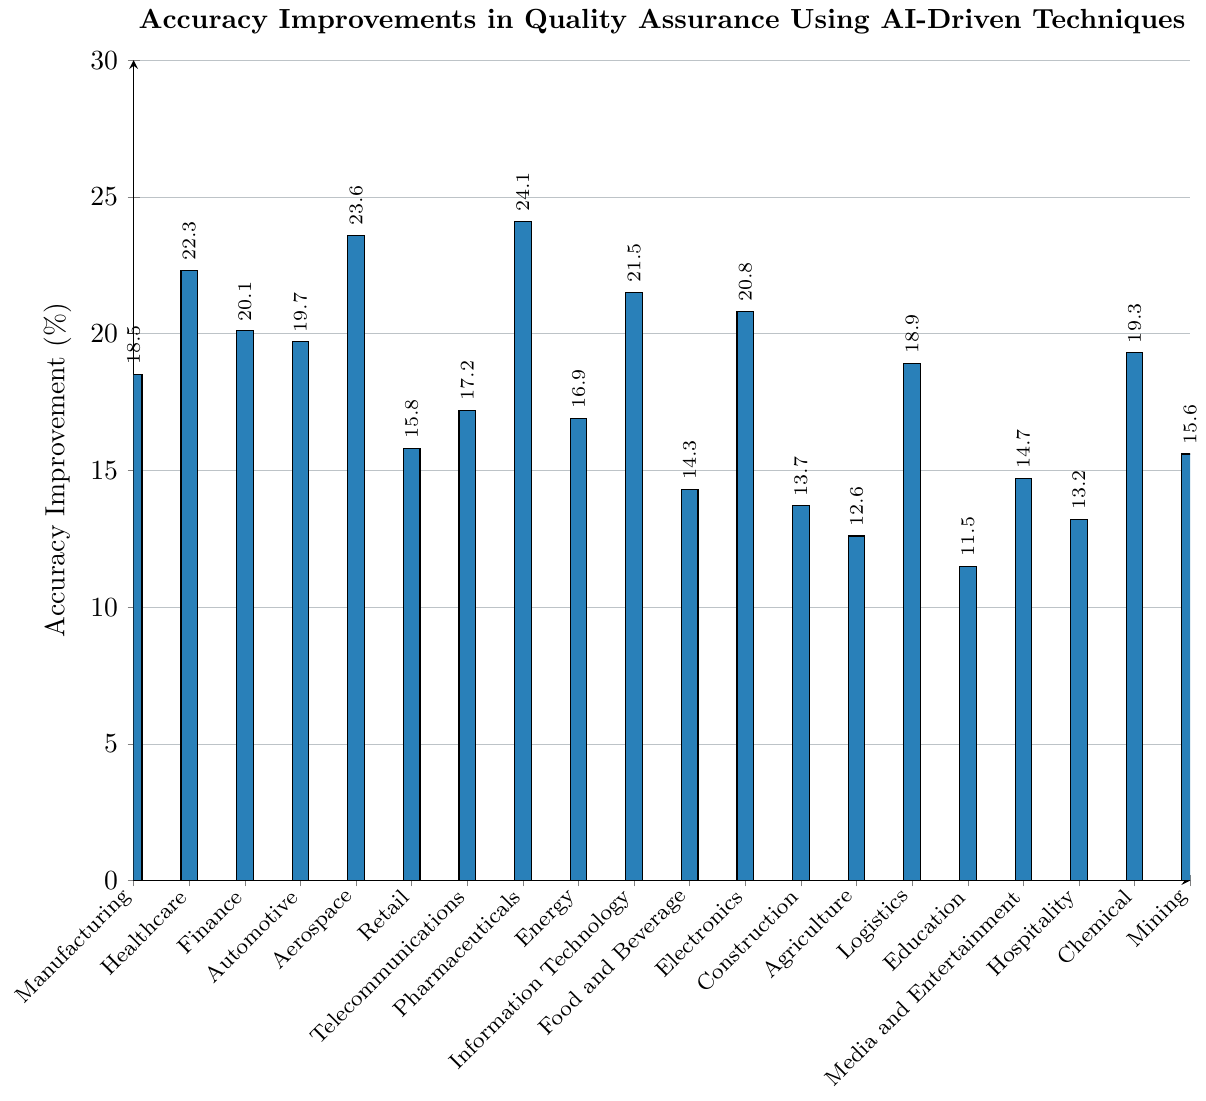Which industry has the highest accuracy improvement percentage? Look for the tallest bar on the chart. The Pharmaceuticals industry has the highest bar.
Answer: Pharmaceuticals Which industry has the lowest accuracy improvement percentage? Locate the shortest bar on the chart. The Education industry has the shortest bar.
Answer: Education How much higher is the accuracy improvement in Healthcare compared to Retail? Healthcare has an improvement of 22.3%, and Retail has 15.8%. Subtract Retail's percentage from Healthcare's: 22.3 - 15.8 = 6.5%
Answer: 6.5% What's the average accuracy improvement percentage across all industries? Sum all the percentages and divide by the number of industries: (18.5 + 22.3 + 20.1 + 19.7 + 23.6 + 15.8 + 17.2 + 24.1 + 16.9 + 21.5 + 14.3 + 20.8 + 13.7 + 12.6 + 18.9 + 11.5 + 14.7 + 13.2 + 19.3 + 15.6) / 20 = 18.013%
Answer: 18.013% Which industry has a smaller accuracy improvement, Media and Entertainment or Hospitality? Compare the heights of the bars for Media and Entertainment (14.7%) and Hospitality (13.2%).
Answer: Hospitality How many industries have an accuracy improvement percentage greater than 20%? Count the bars that are higher than the 20% mark: Healthcare, Aerospace, Pharmaceuticals, Information Technology, and Electronics = 5 industries.
Answer: 5 What is the difference in accuracy improvement between Manufacturing and Agriculture? Manufacturing's percentage is 18.5% and Agriculture's is 12.6%. Subtract Agriculture's percentage from Manufacturing's: 18.5 - 12.6 = 5.9%
Answer: 5.9% Which has a higher value: the sum of accuracy improvements in Logistics and Media and Entertainment, or Construction and Mining? Calculate both sums: Logistics (18.9) + Media and Entertainment (14.7) = 33.6; Construction (13.7) + Mining (15.6) = 29.3. Compare the two sums.
Answer: Logistics and Media and Entertainment Which sectors fall below the 15% accuracy improvement mark? Identify all sectors with bars below 15%: Food and Beverage (14.3%), Construction (13.7%), Agriculture (12.6%), Education (11.5%), Hospitality (13.2%)
Answer: Food and Beverage, Construction, Agriculture, Education, Hospitality What is the range of accuracy improvements in quality assurance processes across these industries? Find the difference between the highest and lowest values: Pharmaceuticals (24.1%) - Education (11.5%) = 12.6%
Answer: 12.6% 